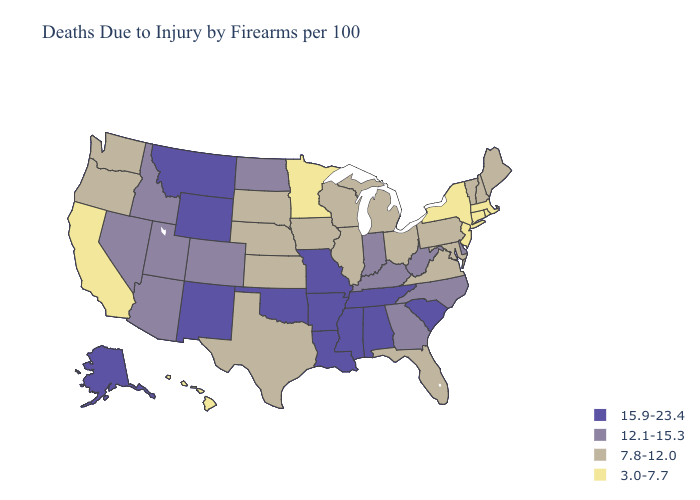Name the states that have a value in the range 15.9-23.4?
Answer briefly. Alabama, Alaska, Arkansas, Louisiana, Mississippi, Missouri, Montana, New Mexico, Oklahoma, South Carolina, Tennessee, Wyoming. Does the first symbol in the legend represent the smallest category?
Be succinct. No. What is the lowest value in states that border Nevada?
Give a very brief answer. 3.0-7.7. What is the highest value in the South ?
Concise answer only. 15.9-23.4. Which states hav the highest value in the MidWest?
Short answer required. Missouri. Does North Dakota have the lowest value in the USA?
Be succinct. No. Name the states that have a value in the range 7.8-12.0?
Short answer required. Florida, Illinois, Iowa, Kansas, Maine, Maryland, Michigan, Nebraska, New Hampshire, Ohio, Oregon, Pennsylvania, South Dakota, Texas, Vermont, Virginia, Washington, Wisconsin. Name the states that have a value in the range 7.8-12.0?
Write a very short answer. Florida, Illinois, Iowa, Kansas, Maine, Maryland, Michigan, Nebraska, New Hampshire, Ohio, Oregon, Pennsylvania, South Dakota, Texas, Vermont, Virginia, Washington, Wisconsin. Does Wisconsin have a higher value than Oklahoma?
Concise answer only. No. Does Tennessee have the lowest value in the USA?
Quick response, please. No. Which states hav the highest value in the South?
Write a very short answer. Alabama, Arkansas, Louisiana, Mississippi, Oklahoma, South Carolina, Tennessee. Among the states that border California , which have the highest value?
Be succinct. Arizona, Nevada. Name the states that have a value in the range 7.8-12.0?
Short answer required. Florida, Illinois, Iowa, Kansas, Maine, Maryland, Michigan, Nebraska, New Hampshire, Ohio, Oregon, Pennsylvania, South Dakota, Texas, Vermont, Virginia, Washington, Wisconsin. Does Ohio have the same value as Montana?
Be succinct. No. Name the states that have a value in the range 3.0-7.7?
Give a very brief answer. California, Connecticut, Hawaii, Massachusetts, Minnesota, New Jersey, New York, Rhode Island. 